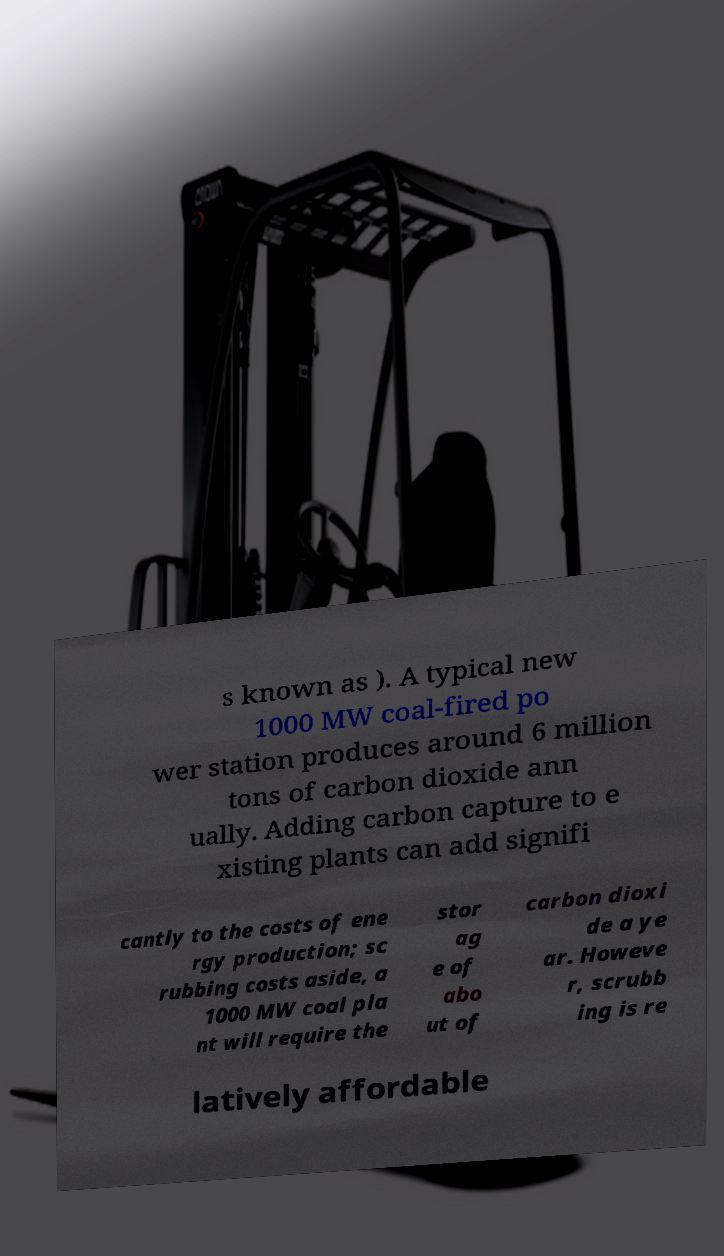Could you extract and type out the text from this image? s known as ). A typical new 1000 MW coal-fired po wer station produces around 6 million tons of carbon dioxide ann ually. Adding carbon capture to e xisting plants can add signifi cantly to the costs of ene rgy production; sc rubbing costs aside, a 1000 MW coal pla nt will require the stor ag e of abo ut of carbon dioxi de a ye ar. Howeve r, scrubb ing is re latively affordable 